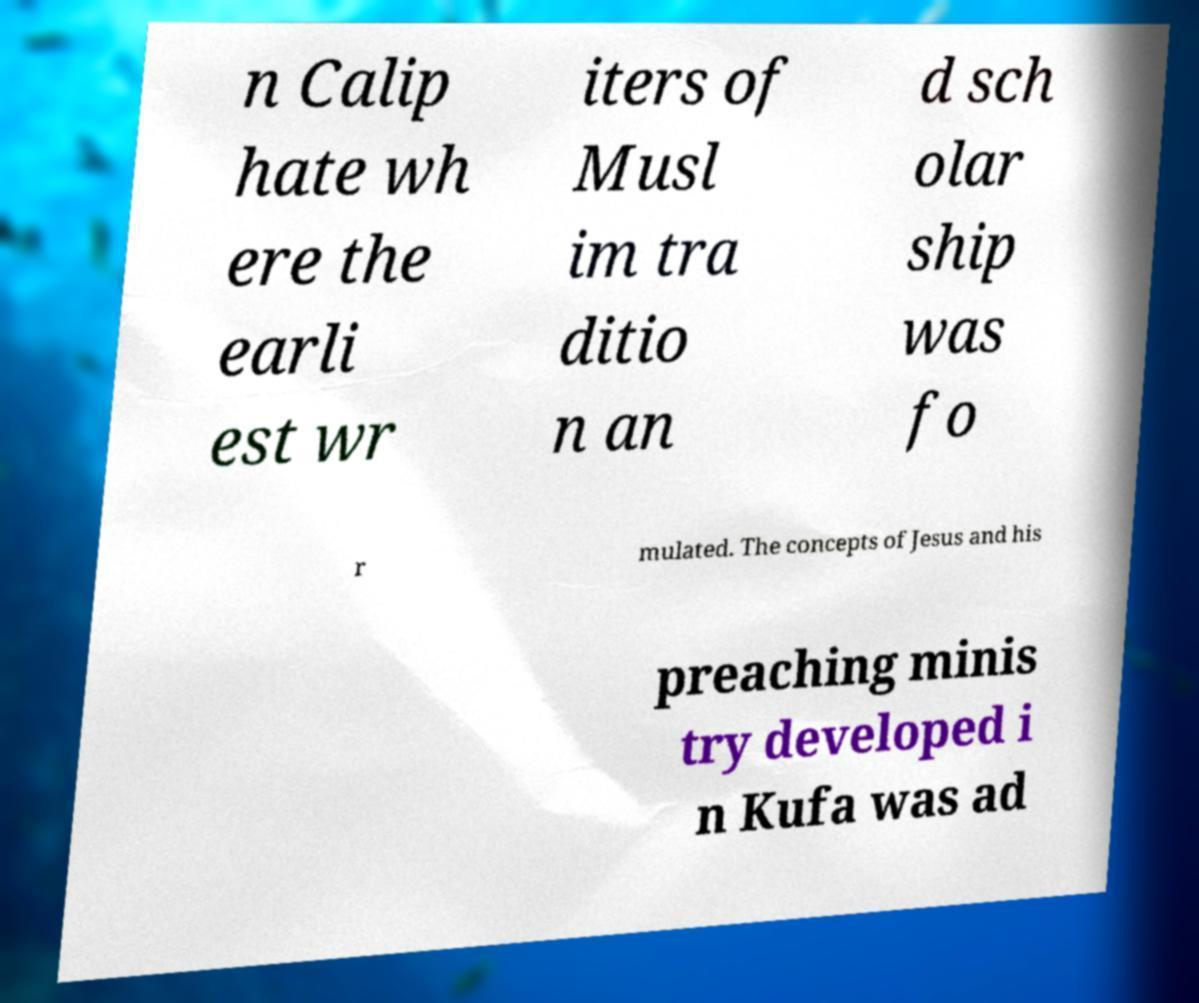Can you accurately transcribe the text from the provided image for me? n Calip hate wh ere the earli est wr iters of Musl im tra ditio n an d sch olar ship was fo r mulated. The concepts of Jesus and his preaching minis try developed i n Kufa was ad 